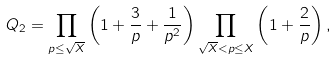Convert formula to latex. <formula><loc_0><loc_0><loc_500><loc_500>Q _ { 2 } = \prod _ { p \leq \sqrt { X } } \left ( 1 + \frac { 3 } { p } + \frac { 1 } { p ^ { 2 } } \right ) \prod _ { \sqrt { X } < p \leq X } \left ( 1 + \frac { 2 } { p } \right ) ,</formula> 